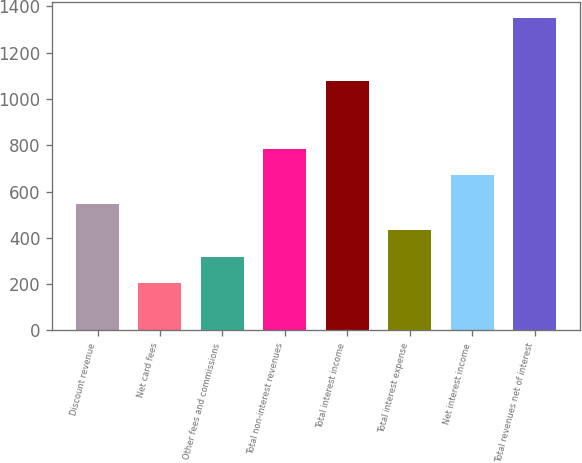Convert chart to OTSL. <chart><loc_0><loc_0><loc_500><loc_500><bar_chart><fcel>Discount revenue<fcel>Net card fees<fcel>Other fees and commissions<fcel>Total non-interest revenues<fcel>Total interest income<fcel>Total interest expense<fcel>Net interest income<fcel>Total revenues net of interest<nl><fcel>548.4<fcel>204<fcel>318.8<fcel>784.8<fcel>1078<fcel>433.6<fcel>670<fcel>1352<nl></chart> 